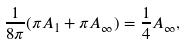Convert formula to latex. <formula><loc_0><loc_0><loc_500><loc_500>\frac { 1 } { 8 \pi } ( \pi A _ { 1 } + \pi A _ { \infty } ) = \frac { 1 } { 4 } A _ { \infty } ,</formula> 